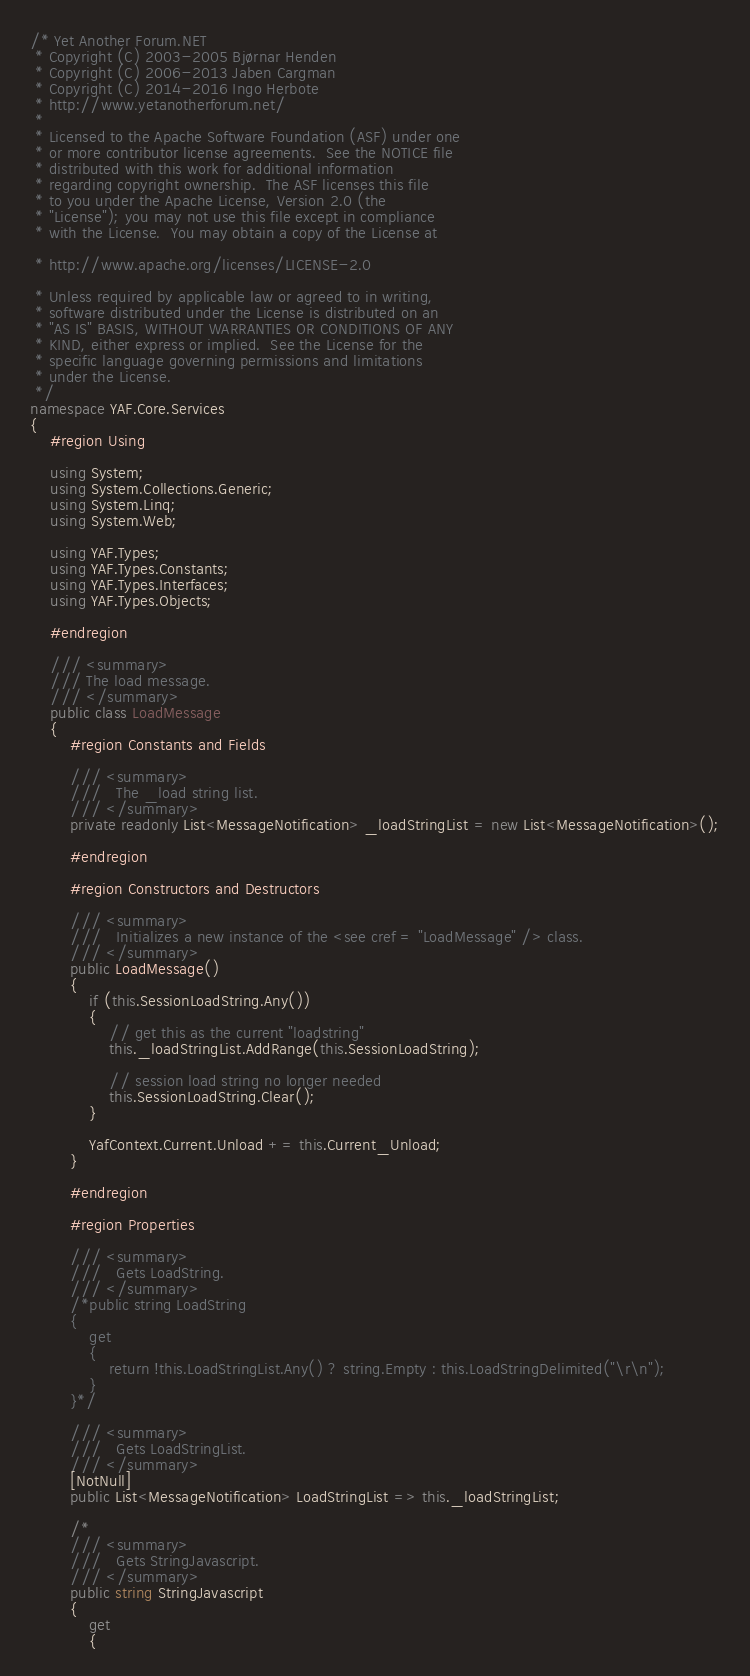Convert code to text. <code><loc_0><loc_0><loc_500><loc_500><_C#_>/* Yet Another Forum.NET
 * Copyright (C) 2003-2005 Bjørnar Henden
 * Copyright (C) 2006-2013 Jaben Cargman
 * Copyright (C) 2014-2016 Ingo Herbote
 * http://www.yetanotherforum.net/
 *
 * Licensed to the Apache Software Foundation (ASF) under one
 * or more contributor license agreements.  See the NOTICE file
 * distributed with this work for additional information
 * regarding copyright ownership.  The ASF licenses this file
 * to you under the Apache License, Version 2.0 (the
 * "License"); you may not use this file except in compliance
 * with the License.  You may obtain a copy of the License at

 * http://www.apache.org/licenses/LICENSE-2.0

 * Unless required by applicable law or agreed to in writing,
 * software distributed under the License is distributed on an
 * "AS IS" BASIS, WITHOUT WARRANTIES OR CONDITIONS OF ANY
 * KIND, either express or implied.  See the License for the
 * specific language governing permissions and limitations
 * under the License.
 */
namespace YAF.Core.Services
{
    #region Using

    using System;
    using System.Collections.Generic;
    using System.Linq;
    using System.Web;

    using YAF.Types;
    using YAF.Types.Constants;
    using YAF.Types.Interfaces;
    using YAF.Types.Objects;

    #endregion

    /// <summary>
    /// The load message.
    /// </summary>
    public class LoadMessage
    {
        #region Constants and Fields

        /// <summary>
        ///   The _load string list.
        /// </summary>
        private readonly List<MessageNotification> _loadStringList = new List<MessageNotification>();

        #endregion

        #region Constructors and Destructors

        /// <summary>
        ///   Initializes a new instance of the <see cref = "LoadMessage" /> class.
        /// </summary>
        public LoadMessage()
        {
            if (this.SessionLoadString.Any())
            {
                // get this as the current "loadstring"
                this._loadStringList.AddRange(this.SessionLoadString);

                // session load string no longer needed
                this.SessionLoadString.Clear();
            }

            YafContext.Current.Unload += this.Current_Unload;
        }

        #endregion

        #region Properties

        /// <summary>
        ///   Gets LoadString.
        /// </summary>
        /*public string LoadString
        {
            get
            {
                return !this.LoadStringList.Any() ? string.Empty : this.LoadStringDelimited("\r\n");
            }
        }*/

        /// <summary>
        ///   Gets LoadStringList.
        /// </summary>
        [NotNull]
        public List<MessageNotification> LoadStringList => this._loadStringList;

        /*
        /// <summary>
        ///   Gets StringJavascript.
        /// </summary>
        public string StringJavascript
        {
            get
            {</code> 